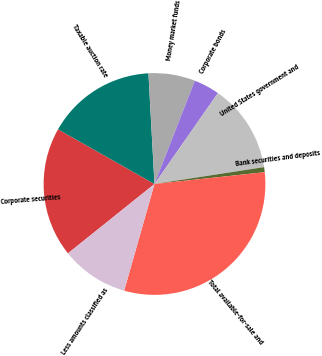Convert chart. <chart><loc_0><loc_0><loc_500><loc_500><pie_chart><fcel>Corporate securities<fcel>Taxable auction rate<fcel>Money market funds<fcel>Corporate bonds<fcel>United States government and<fcel>Bank securities and deposits<fcel>Total available-for-sale and<fcel>Less amounts classified as<nl><fcel>18.96%<fcel>15.92%<fcel>6.8%<fcel>3.76%<fcel>12.88%<fcel>0.73%<fcel>31.11%<fcel>9.84%<nl></chart> 